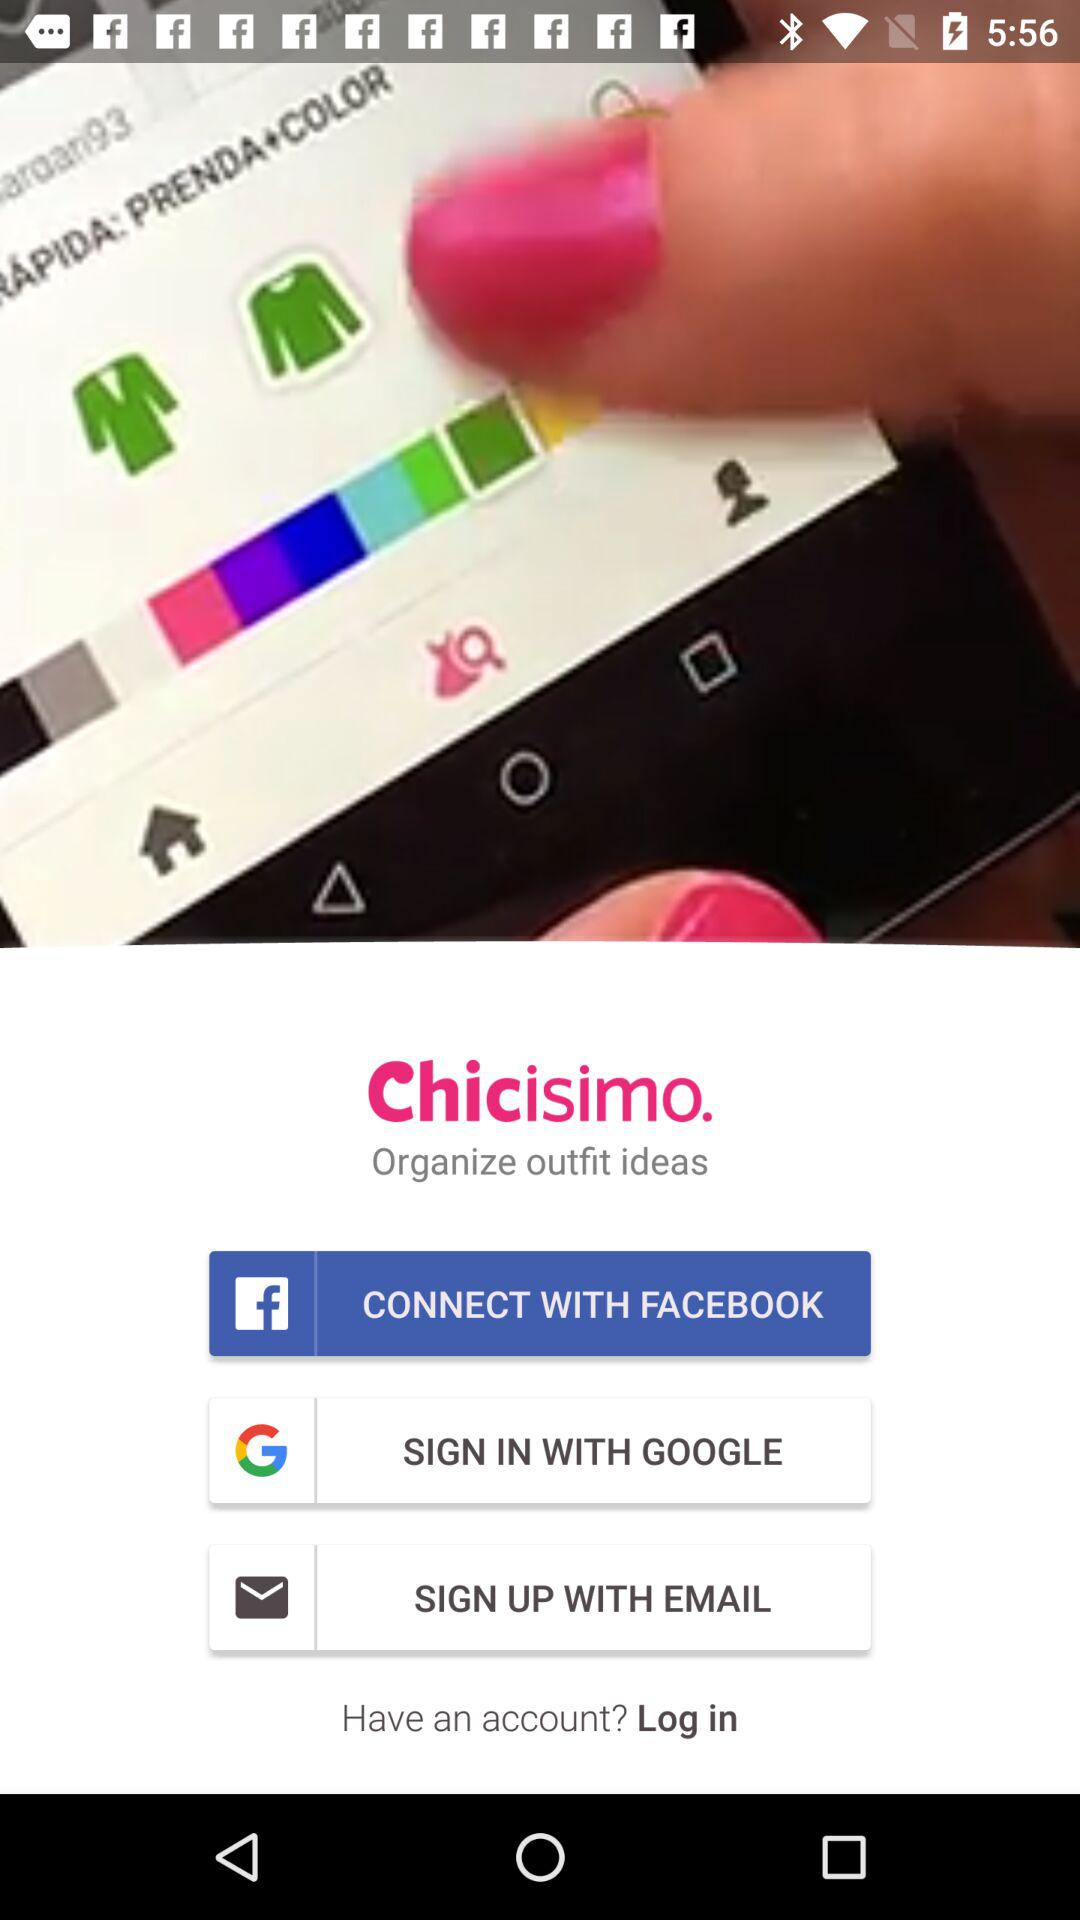How many sign-in options are there?
Answer the question using a single word or phrase. 3 